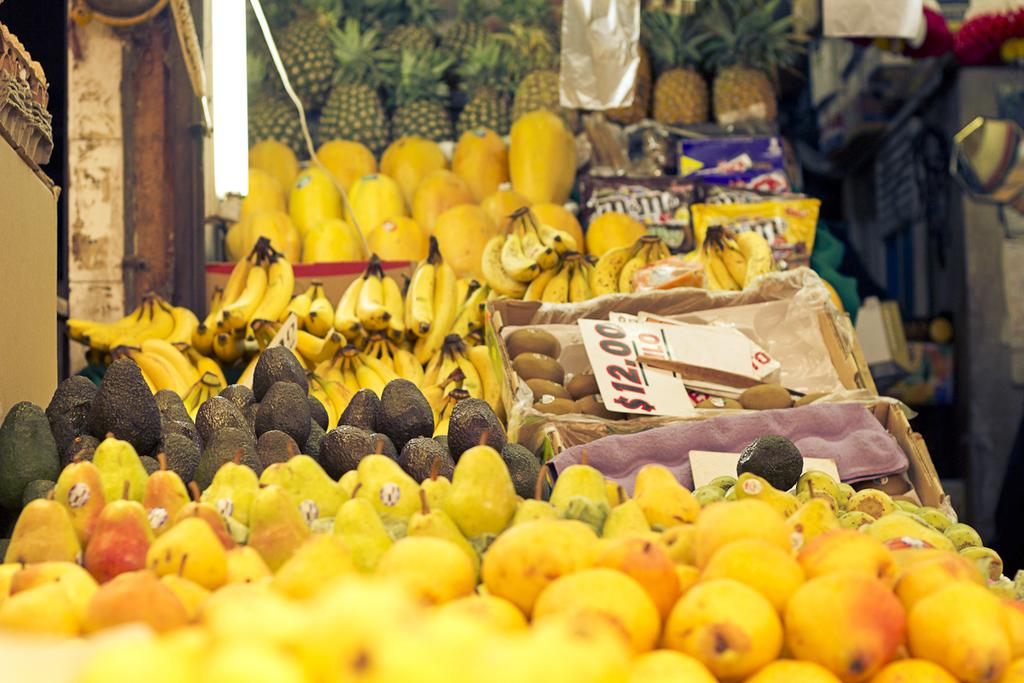What type of food can be seen in the image? There are fruits in the image. How are the fruits arranged in the image? The fruits are in baskets in the image. What type of tool is being used to dig in the image? There is no tool or digging activity present in the image; it features fruits in baskets. What sound can be heard coming from the whistle in the image? There is no whistle present in the image, so it's not possible to determine what sound might be heard. 